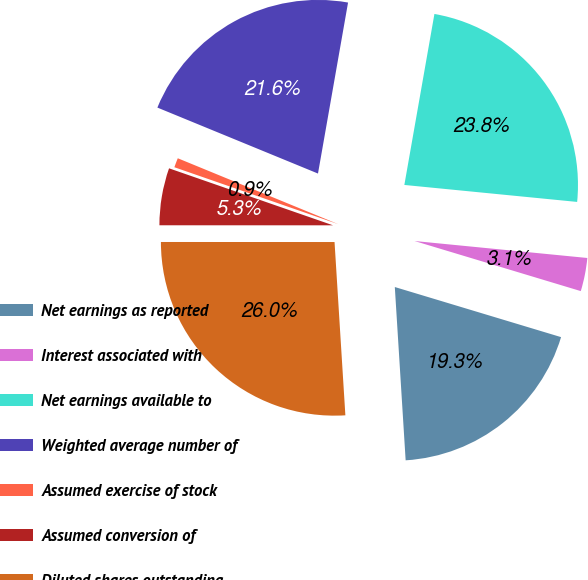<chart> <loc_0><loc_0><loc_500><loc_500><pie_chart><fcel>Net earnings as reported<fcel>Interest associated with<fcel>Net earnings available to<fcel>Weighted average number of<fcel>Assumed exercise of stock<fcel>Assumed conversion of<fcel>Diluted shares outstanding<nl><fcel>19.35%<fcel>3.1%<fcel>23.79%<fcel>21.57%<fcel>0.88%<fcel>5.32%<fcel>26.0%<nl></chart> 